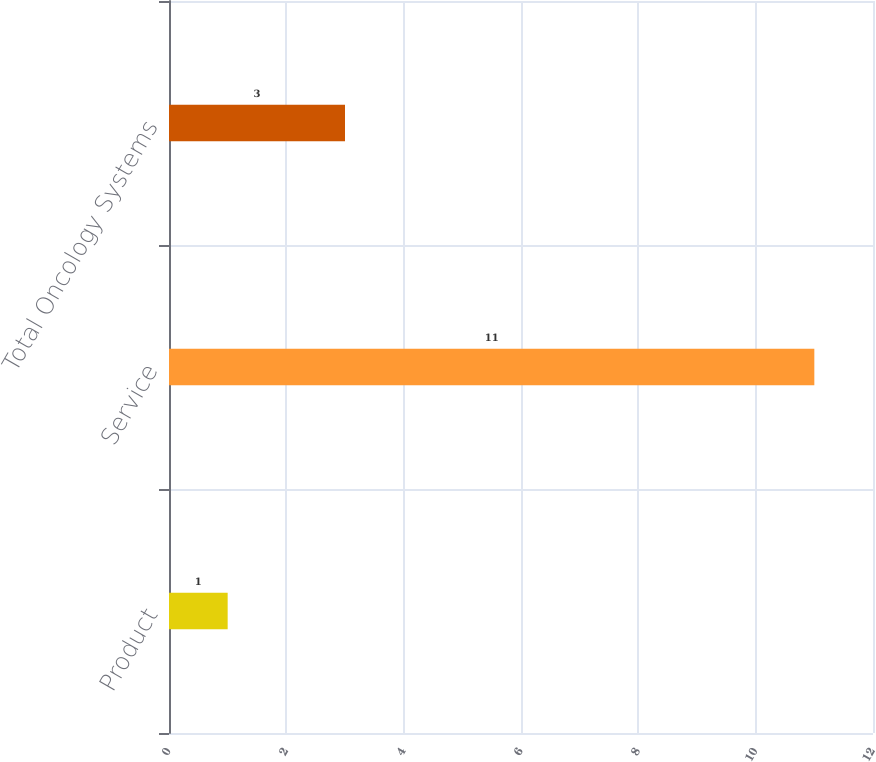<chart> <loc_0><loc_0><loc_500><loc_500><bar_chart><fcel>Product<fcel>Service<fcel>Total Oncology Systems<nl><fcel>1<fcel>11<fcel>3<nl></chart> 